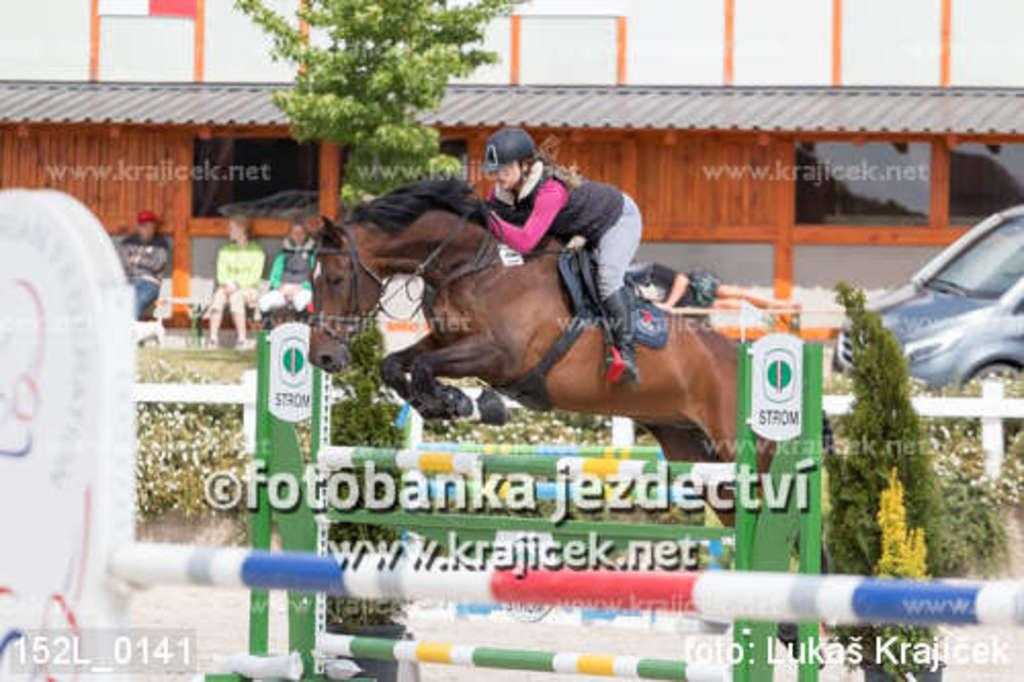What is the main subject of the image? The main subject of the image is a person sitting on a horse. What is the horse doing in the image? The horse is taking a jump in the image. What else can be seen in the image? There is a car on the right side of the image. Is the horse stuck in quicksand in the image? No, the horse is not stuck in quicksand in the image; it is taking a jump. What message of peace can be seen in the image? There is no message of peace present in the image; it features a person sitting on a horse taking a jump and a car on the right side. 